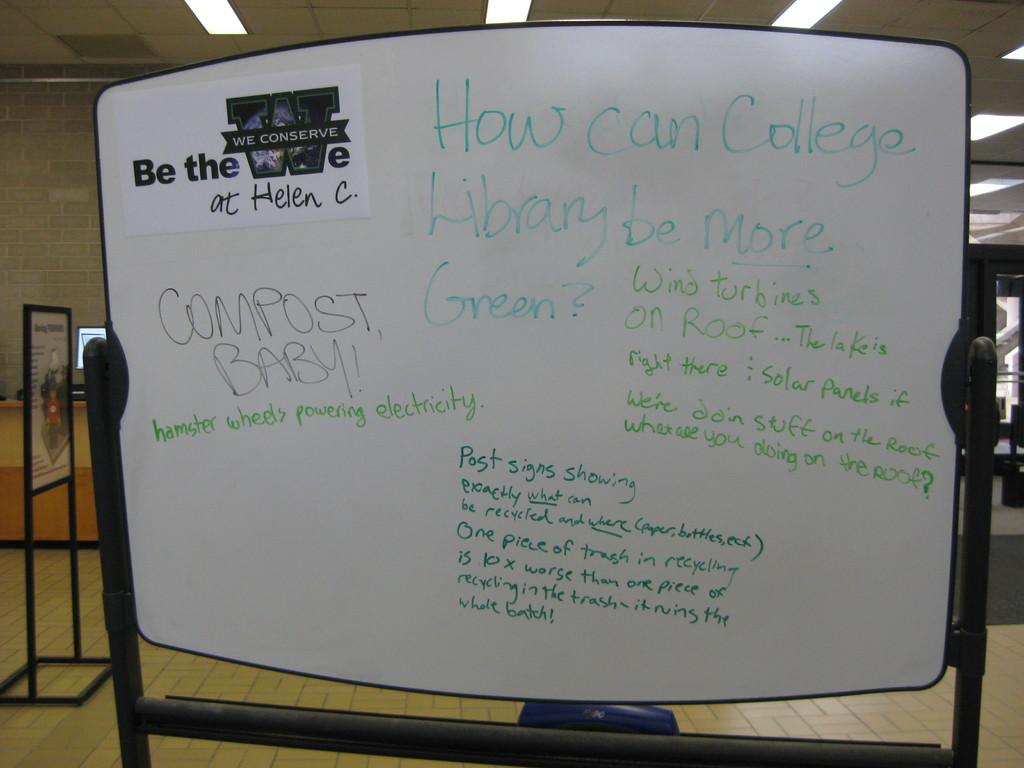<image>
Relay a brief, clear account of the picture shown. the word compost is on a white sign 